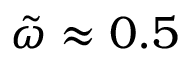<formula> <loc_0><loc_0><loc_500><loc_500>\tilde { \omega } \approx 0 . 5</formula> 